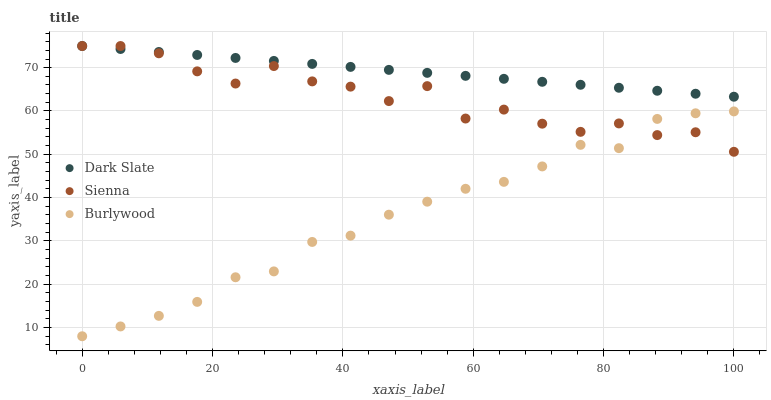Does Burlywood have the minimum area under the curve?
Answer yes or no. Yes. Does Dark Slate have the maximum area under the curve?
Answer yes or no. Yes. Does Dark Slate have the minimum area under the curve?
Answer yes or no. No. Does Burlywood have the maximum area under the curve?
Answer yes or no. No. Is Dark Slate the smoothest?
Answer yes or no. Yes. Is Sienna the roughest?
Answer yes or no. Yes. Is Burlywood the smoothest?
Answer yes or no. No. Is Burlywood the roughest?
Answer yes or no. No. Does Burlywood have the lowest value?
Answer yes or no. Yes. Does Dark Slate have the lowest value?
Answer yes or no. No. Does Dark Slate have the highest value?
Answer yes or no. Yes. Does Burlywood have the highest value?
Answer yes or no. No. Is Burlywood less than Dark Slate?
Answer yes or no. Yes. Is Dark Slate greater than Burlywood?
Answer yes or no. Yes. Does Sienna intersect Dark Slate?
Answer yes or no. Yes. Is Sienna less than Dark Slate?
Answer yes or no. No. Is Sienna greater than Dark Slate?
Answer yes or no. No. Does Burlywood intersect Dark Slate?
Answer yes or no. No. 